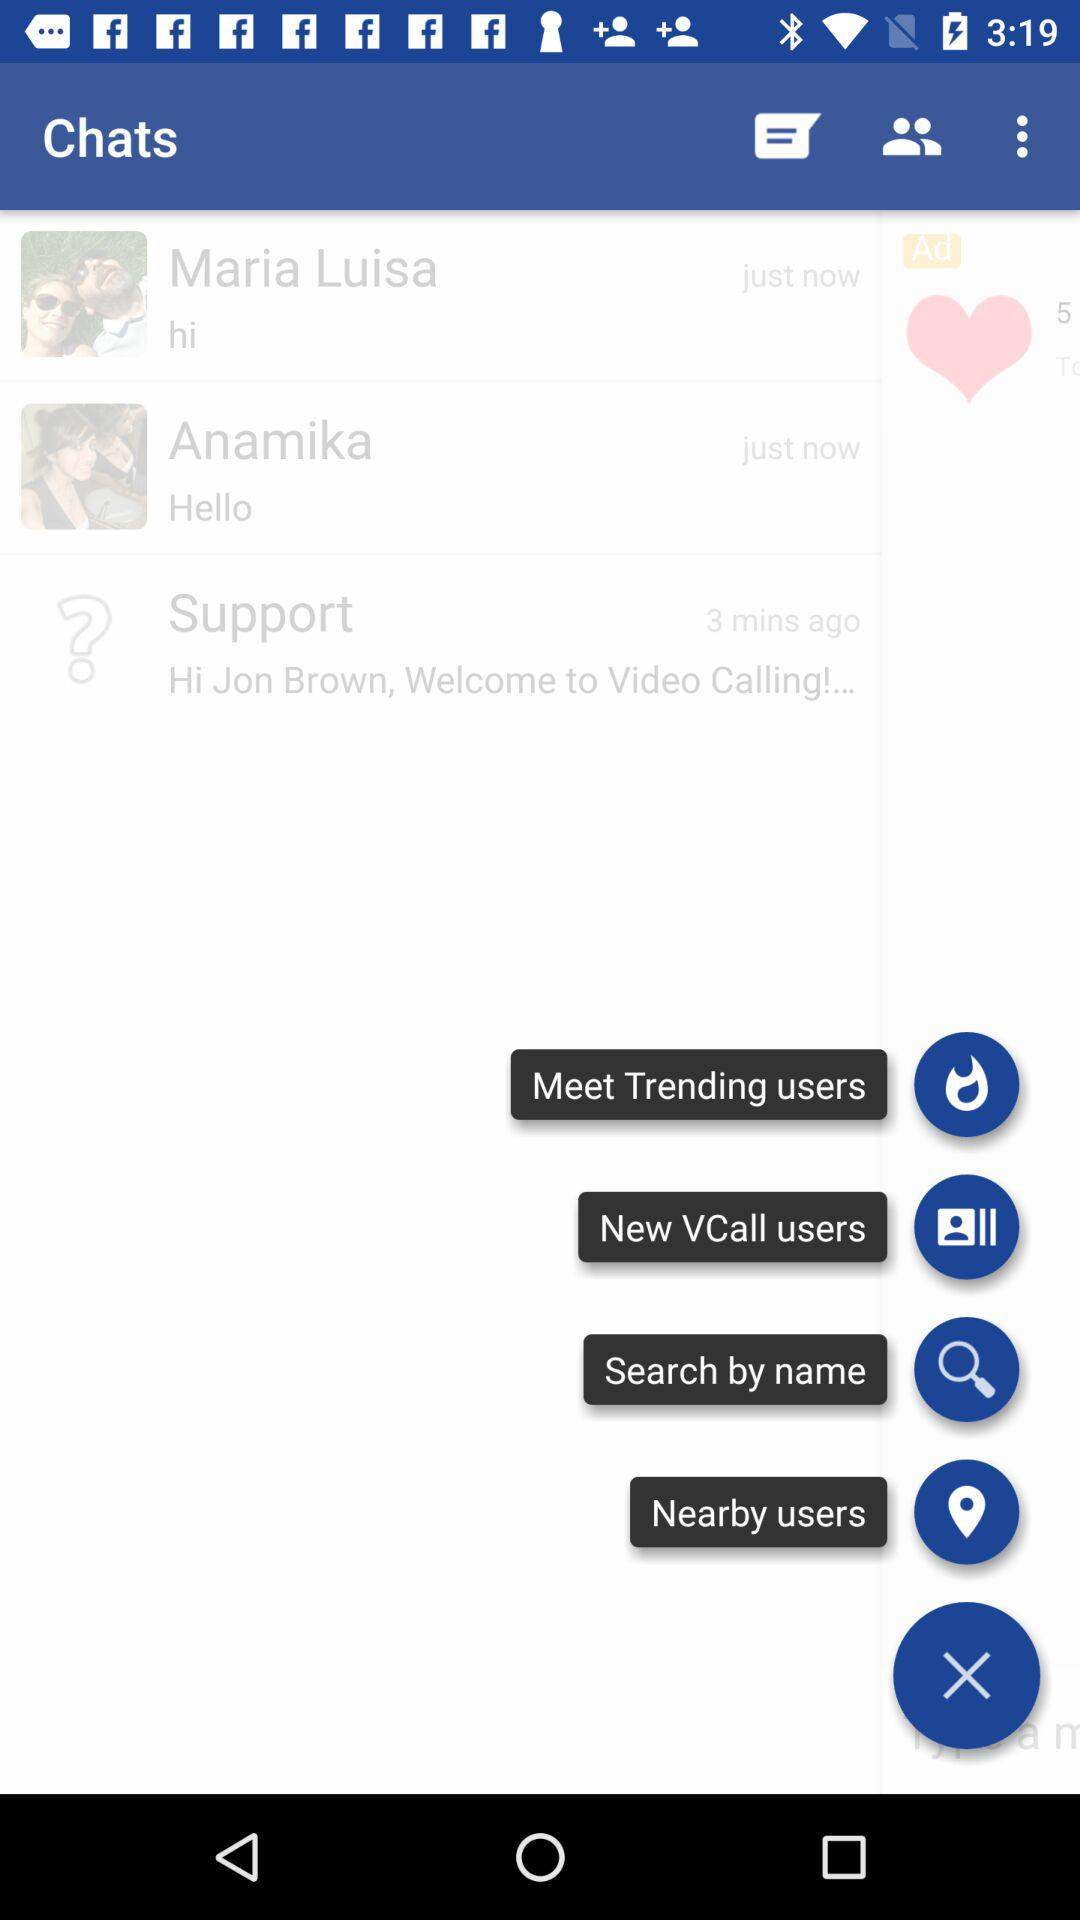When was Maria Luisa's message received in the chat? The message was received just now. 